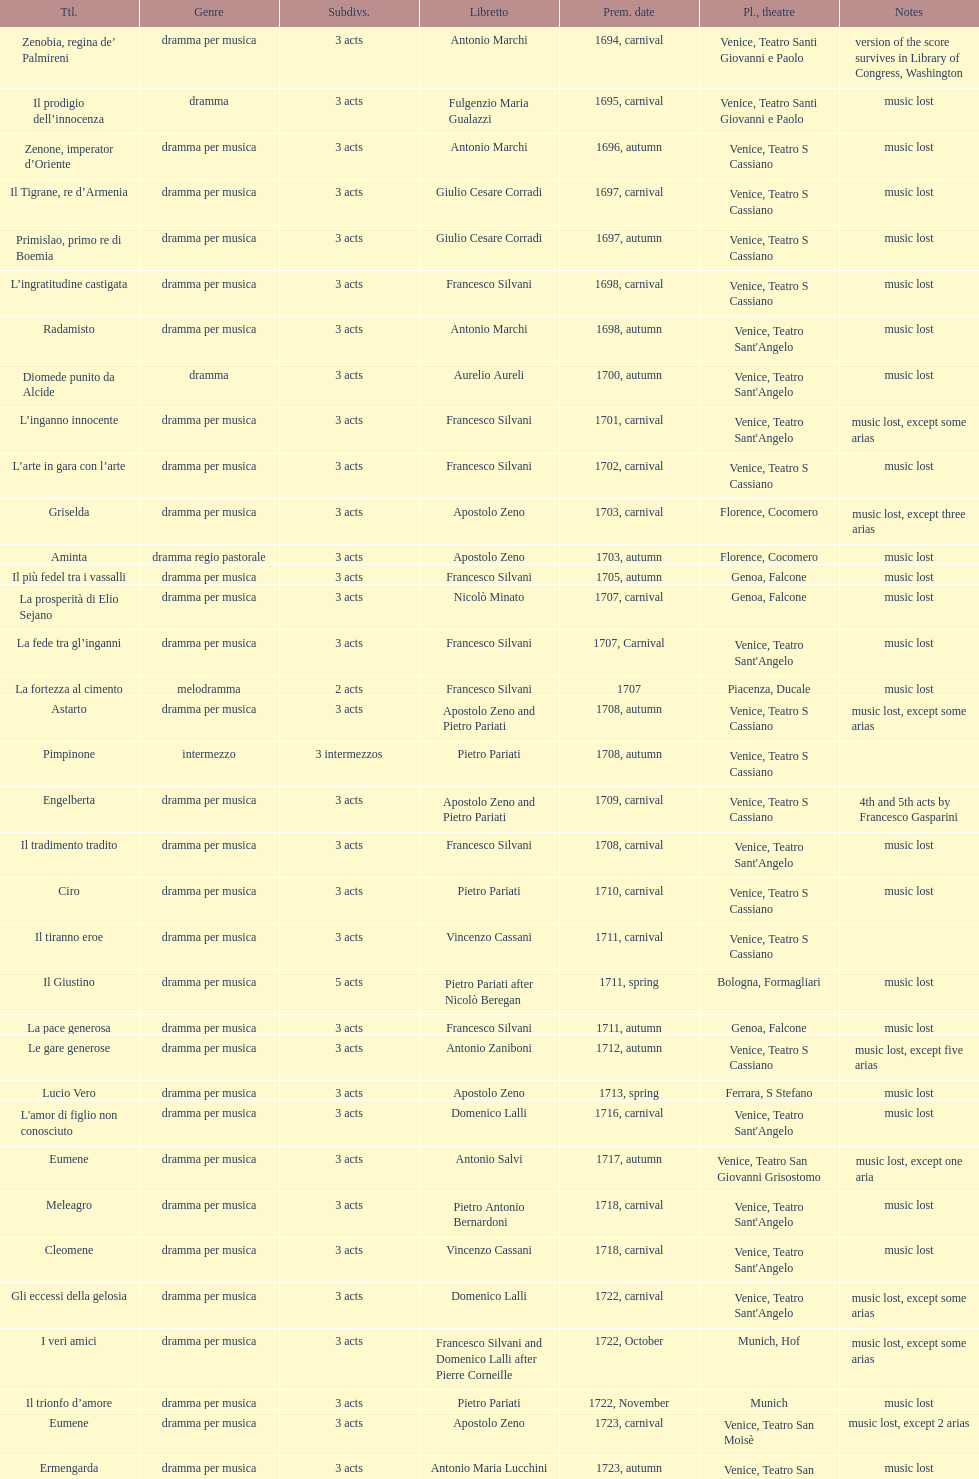How many were released after zenone, imperator d'oriente? 52. 